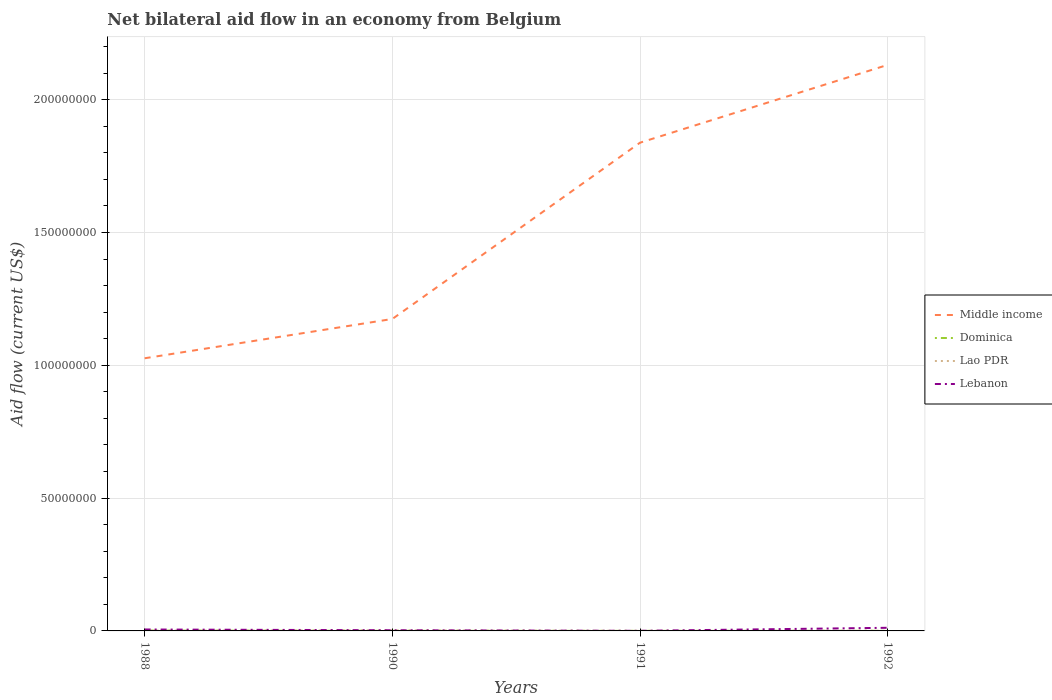How many different coloured lines are there?
Your answer should be very brief. 4. Across all years, what is the maximum net bilateral aid flow in Dominica?
Offer a terse response. 2.00e+04. In which year was the net bilateral aid flow in Lebanon maximum?
Give a very brief answer. 1991. What is the difference between the highest and the second highest net bilateral aid flow in Lao PDR?
Provide a short and direct response. 2.10e+05. What is the difference between the highest and the lowest net bilateral aid flow in Lebanon?
Provide a short and direct response. 2. How many lines are there?
Provide a succinct answer. 4. How many legend labels are there?
Your answer should be compact. 4. How are the legend labels stacked?
Provide a succinct answer. Vertical. What is the title of the graph?
Your response must be concise. Net bilateral aid flow in an economy from Belgium. What is the label or title of the Y-axis?
Ensure brevity in your answer.  Aid flow (current US$). What is the Aid flow (current US$) in Middle income in 1988?
Give a very brief answer. 1.03e+08. What is the Aid flow (current US$) of Dominica in 1988?
Your response must be concise. 1.20e+05. What is the Aid flow (current US$) of Lebanon in 1988?
Provide a succinct answer. 5.40e+05. What is the Aid flow (current US$) of Middle income in 1990?
Provide a short and direct response. 1.17e+08. What is the Aid flow (current US$) in Dominica in 1990?
Offer a very short reply. 4.00e+04. What is the Aid flow (current US$) of Lao PDR in 1990?
Your answer should be compact. 2.30e+05. What is the Aid flow (current US$) of Middle income in 1991?
Your answer should be very brief. 1.84e+08. What is the Aid flow (current US$) in Dominica in 1991?
Your answer should be very brief. 2.00e+04. What is the Aid flow (current US$) of Middle income in 1992?
Provide a short and direct response. 2.13e+08. What is the Aid flow (current US$) in Lebanon in 1992?
Your response must be concise. 1.18e+06. Across all years, what is the maximum Aid flow (current US$) in Middle income?
Your answer should be very brief. 2.13e+08. Across all years, what is the maximum Aid flow (current US$) in Dominica?
Offer a terse response. 1.20e+05. Across all years, what is the maximum Aid flow (current US$) in Lao PDR?
Provide a short and direct response. 2.30e+05. Across all years, what is the maximum Aid flow (current US$) in Lebanon?
Make the answer very short. 1.18e+06. Across all years, what is the minimum Aid flow (current US$) of Middle income?
Provide a succinct answer. 1.03e+08. Across all years, what is the minimum Aid flow (current US$) of Dominica?
Offer a terse response. 2.00e+04. Across all years, what is the minimum Aid flow (current US$) of Lao PDR?
Offer a very short reply. 2.00e+04. Across all years, what is the minimum Aid flow (current US$) of Lebanon?
Ensure brevity in your answer.  4.00e+04. What is the total Aid flow (current US$) in Middle income in the graph?
Provide a succinct answer. 6.17e+08. What is the total Aid flow (current US$) in Lao PDR in the graph?
Make the answer very short. 4.30e+05. What is the total Aid flow (current US$) in Lebanon in the graph?
Provide a short and direct response. 2.01e+06. What is the difference between the Aid flow (current US$) of Middle income in 1988 and that in 1990?
Provide a succinct answer. -1.48e+07. What is the difference between the Aid flow (current US$) of Dominica in 1988 and that in 1990?
Your answer should be very brief. 8.00e+04. What is the difference between the Aid flow (current US$) in Lebanon in 1988 and that in 1990?
Offer a very short reply. 2.90e+05. What is the difference between the Aid flow (current US$) in Middle income in 1988 and that in 1991?
Ensure brevity in your answer.  -8.12e+07. What is the difference between the Aid flow (current US$) in Dominica in 1988 and that in 1991?
Your answer should be compact. 1.00e+05. What is the difference between the Aid flow (current US$) in Lao PDR in 1988 and that in 1991?
Offer a very short reply. 9.00e+04. What is the difference between the Aid flow (current US$) in Lebanon in 1988 and that in 1991?
Keep it short and to the point. 5.00e+05. What is the difference between the Aid flow (current US$) of Middle income in 1988 and that in 1992?
Ensure brevity in your answer.  -1.10e+08. What is the difference between the Aid flow (current US$) in Lao PDR in 1988 and that in 1992?
Your response must be concise. 4.00e+04. What is the difference between the Aid flow (current US$) of Lebanon in 1988 and that in 1992?
Offer a terse response. -6.40e+05. What is the difference between the Aid flow (current US$) of Middle income in 1990 and that in 1991?
Your response must be concise. -6.64e+07. What is the difference between the Aid flow (current US$) of Lao PDR in 1990 and that in 1991?
Keep it short and to the point. 2.10e+05. What is the difference between the Aid flow (current US$) of Middle income in 1990 and that in 1992?
Offer a terse response. -9.57e+07. What is the difference between the Aid flow (current US$) in Dominica in 1990 and that in 1992?
Your response must be concise. 0. What is the difference between the Aid flow (current US$) of Lebanon in 1990 and that in 1992?
Your response must be concise. -9.30e+05. What is the difference between the Aid flow (current US$) in Middle income in 1991 and that in 1992?
Your answer should be compact. -2.93e+07. What is the difference between the Aid flow (current US$) in Dominica in 1991 and that in 1992?
Offer a very short reply. -2.00e+04. What is the difference between the Aid flow (current US$) in Lebanon in 1991 and that in 1992?
Your answer should be very brief. -1.14e+06. What is the difference between the Aid flow (current US$) of Middle income in 1988 and the Aid flow (current US$) of Dominica in 1990?
Provide a succinct answer. 1.03e+08. What is the difference between the Aid flow (current US$) in Middle income in 1988 and the Aid flow (current US$) in Lao PDR in 1990?
Provide a short and direct response. 1.02e+08. What is the difference between the Aid flow (current US$) of Middle income in 1988 and the Aid flow (current US$) of Lebanon in 1990?
Keep it short and to the point. 1.02e+08. What is the difference between the Aid flow (current US$) in Dominica in 1988 and the Aid flow (current US$) in Lebanon in 1990?
Your response must be concise. -1.30e+05. What is the difference between the Aid flow (current US$) of Lao PDR in 1988 and the Aid flow (current US$) of Lebanon in 1990?
Make the answer very short. -1.40e+05. What is the difference between the Aid flow (current US$) in Middle income in 1988 and the Aid flow (current US$) in Dominica in 1991?
Make the answer very short. 1.03e+08. What is the difference between the Aid flow (current US$) in Middle income in 1988 and the Aid flow (current US$) in Lao PDR in 1991?
Keep it short and to the point. 1.03e+08. What is the difference between the Aid flow (current US$) of Middle income in 1988 and the Aid flow (current US$) of Lebanon in 1991?
Your answer should be compact. 1.03e+08. What is the difference between the Aid flow (current US$) of Dominica in 1988 and the Aid flow (current US$) of Lao PDR in 1991?
Make the answer very short. 1.00e+05. What is the difference between the Aid flow (current US$) of Lao PDR in 1988 and the Aid flow (current US$) of Lebanon in 1991?
Offer a very short reply. 7.00e+04. What is the difference between the Aid flow (current US$) of Middle income in 1988 and the Aid flow (current US$) of Dominica in 1992?
Offer a very short reply. 1.03e+08. What is the difference between the Aid flow (current US$) of Middle income in 1988 and the Aid flow (current US$) of Lao PDR in 1992?
Offer a very short reply. 1.03e+08. What is the difference between the Aid flow (current US$) of Middle income in 1988 and the Aid flow (current US$) of Lebanon in 1992?
Your answer should be very brief. 1.01e+08. What is the difference between the Aid flow (current US$) of Dominica in 1988 and the Aid flow (current US$) of Lebanon in 1992?
Your answer should be very brief. -1.06e+06. What is the difference between the Aid flow (current US$) in Lao PDR in 1988 and the Aid flow (current US$) in Lebanon in 1992?
Make the answer very short. -1.07e+06. What is the difference between the Aid flow (current US$) of Middle income in 1990 and the Aid flow (current US$) of Dominica in 1991?
Offer a terse response. 1.17e+08. What is the difference between the Aid flow (current US$) of Middle income in 1990 and the Aid flow (current US$) of Lao PDR in 1991?
Keep it short and to the point. 1.17e+08. What is the difference between the Aid flow (current US$) in Middle income in 1990 and the Aid flow (current US$) in Lebanon in 1991?
Your answer should be very brief. 1.17e+08. What is the difference between the Aid flow (current US$) of Dominica in 1990 and the Aid flow (current US$) of Lao PDR in 1991?
Offer a terse response. 2.00e+04. What is the difference between the Aid flow (current US$) in Dominica in 1990 and the Aid flow (current US$) in Lebanon in 1991?
Make the answer very short. 0. What is the difference between the Aid flow (current US$) in Lao PDR in 1990 and the Aid flow (current US$) in Lebanon in 1991?
Your response must be concise. 1.90e+05. What is the difference between the Aid flow (current US$) in Middle income in 1990 and the Aid flow (current US$) in Dominica in 1992?
Your response must be concise. 1.17e+08. What is the difference between the Aid flow (current US$) in Middle income in 1990 and the Aid flow (current US$) in Lao PDR in 1992?
Give a very brief answer. 1.17e+08. What is the difference between the Aid flow (current US$) of Middle income in 1990 and the Aid flow (current US$) of Lebanon in 1992?
Your answer should be compact. 1.16e+08. What is the difference between the Aid flow (current US$) in Dominica in 1990 and the Aid flow (current US$) in Lebanon in 1992?
Provide a succinct answer. -1.14e+06. What is the difference between the Aid flow (current US$) in Lao PDR in 1990 and the Aid flow (current US$) in Lebanon in 1992?
Offer a very short reply. -9.50e+05. What is the difference between the Aid flow (current US$) of Middle income in 1991 and the Aid flow (current US$) of Dominica in 1992?
Offer a terse response. 1.84e+08. What is the difference between the Aid flow (current US$) of Middle income in 1991 and the Aid flow (current US$) of Lao PDR in 1992?
Provide a succinct answer. 1.84e+08. What is the difference between the Aid flow (current US$) in Middle income in 1991 and the Aid flow (current US$) in Lebanon in 1992?
Make the answer very short. 1.83e+08. What is the difference between the Aid flow (current US$) of Dominica in 1991 and the Aid flow (current US$) of Lebanon in 1992?
Provide a succinct answer. -1.16e+06. What is the difference between the Aid flow (current US$) in Lao PDR in 1991 and the Aid flow (current US$) in Lebanon in 1992?
Provide a short and direct response. -1.16e+06. What is the average Aid flow (current US$) in Middle income per year?
Provide a succinct answer. 1.54e+08. What is the average Aid flow (current US$) of Dominica per year?
Provide a succinct answer. 5.50e+04. What is the average Aid flow (current US$) in Lao PDR per year?
Offer a terse response. 1.08e+05. What is the average Aid flow (current US$) in Lebanon per year?
Your answer should be very brief. 5.02e+05. In the year 1988, what is the difference between the Aid flow (current US$) of Middle income and Aid flow (current US$) of Dominica?
Your response must be concise. 1.03e+08. In the year 1988, what is the difference between the Aid flow (current US$) of Middle income and Aid flow (current US$) of Lao PDR?
Make the answer very short. 1.03e+08. In the year 1988, what is the difference between the Aid flow (current US$) in Middle income and Aid flow (current US$) in Lebanon?
Offer a very short reply. 1.02e+08. In the year 1988, what is the difference between the Aid flow (current US$) in Dominica and Aid flow (current US$) in Lao PDR?
Your answer should be very brief. 10000. In the year 1988, what is the difference between the Aid flow (current US$) in Dominica and Aid flow (current US$) in Lebanon?
Offer a terse response. -4.20e+05. In the year 1988, what is the difference between the Aid flow (current US$) in Lao PDR and Aid flow (current US$) in Lebanon?
Ensure brevity in your answer.  -4.30e+05. In the year 1990, what is the difference between the Aid flow (current US$) of Middle income and Aid flow (current US$) of Dominica?
Keep it short and to the point. 1.17e+08. In the year 1990, what is the difference between the Aid flow (current US$) in Middle income and Aid flow (current US$) in Lao PDR?
Offer a terse response. 1.17e+08. In the year 1990, what is the difference between the Aid flow (current US$) in Middle income and Aid flow (current US$) in Lebanon?
Your response must be concise. 1.17e+08. In the year 1990, what is the difference between the Aid flow (current US$) in Lao PDR and Aid flow (current US$) in Lebanon?
Keep it short and to the point. -2.00e+04. In the year 1991, what is the difference between the Aid flow (current US$) of Middle income and Aid flow (current US$) of Dominica?
Offer a very short reply. 1.84e+08. In the year 1991, what is the difference between the Aid flow (current US$) in Middle income and Aid flow (current US$) in Lao PDR?
Provide a short and direct response. 1.84e+08. In the year 1991, what is the difference between the Aid flow (current US$) in Middle income and Aid flow (current US$) in Lebanon?
Make the answer very short. 1.84e+08. In the year 1991, what is the difference between the Aid flow (current US$) of Dominica and Aid flow (current US$) of Lao PDR?
Ensure brevity in your answer.  0. In the year 1991, what is the difference between the Aid flow (current US$) in Dominica and Aid flow (current US$) in Lebanon?
Your response must be concise. -2.00e+04. In the year 1992, what is the difference between the Aid flow (current US$) in Middle income and Aid flow (current US$) in Dominica?
Make the answer very short. 2.13e+08. In the year 1992, what is the difference between the Aid flow (current US$) in Middle income and Aid flow (current US$) in Lao PDR?
Your answer should be very brief. 2.13e+08. In the year 1992, what is the difference between the Aid flow (current US$) of Middle income and Aid flow (current US$) of Lebanon?
Provide a short and direct response. 2.12e+08. In the year 1992, what is the difference between the Aid flow (current US$) in Dominica and Aid flow (current US$) in Lao PDR?
Give a very brief answer. -3.00e+04. In the year 1992, what is the difference between the Aid flow (current US$) in Dominica and Aid flow (current US$) in Lebanon?
Your answer should be very brief. -1.14e+06. In the year 1992, what is the difference between the Aid flow (current US$) of Lao PDR and Aid flow (current US$) of Lebanon?
Your answer should be very brief. -1.11e+06. What is the ratio of the Aid flow (current US$) in Middle income in 1988 to that in 1990?
Your response must be concise. 0.87. What is the ratio of the Aid flow (current US$) in Lao PDR in 1988 to that in 1990?
Ensure brevity in your answer.  0.48. What is the ratio of the Aid flow (current US$) of Lebanon in 1988 to that in 1990?
Give a very brief answer. 2.16. What is the ratio of the Aid flow (current US$) of Middle income in 1988 to that in 1991?
Your answer should be very brief. 0.56. What is the ratio of the Aid flow (current US$) in Dominica in 1988 to that in 1991?
Ensure brevity in your answer.  6. What is the ratio of the Aid flow (current US$) of Middle income in 1988 to that in 1992?
Your answer should be compact. 0.48. What is the ratio of the Aid flow (current US$) in Dominica in 1988 to that in 1992?
Give a very brief answer. 3. What is the ratio of the Aid flow (current US$) in Lao PDR in 1988 to that in 1992?
Make the answer very short. 1.57. What is the ratio of the Aid flow (current US$) of Lebanon in 1988 to that in 1992?
Offer a terse response. 0.46. What is the ratio of the Aid flow (current US$) of Middle income in 1990 to that in 1991?
Offer a terse response. 0.64. What is the ratio of the Aid flow (current US$) in Lebanon in 1990 to that in 1991?
Provide a short and direct response. 6.25. What is the ratio of the Aid flow (current US$) of Middle income in 1990 to that in 1992?
Offer a terse response. 0.55. What is the ratio of the Aid flow (current US$) of Lao PDR in 1990 to that in 1992?
Your response must be concise. 3.29. What is the ratio of the Aid flow (current US$) in Lebanon in 1990 to that in 1992?
Your answer should be very brief. 0.21. What is the ratio of the Aid flow (current US$) in Middle income in 1991 to that in 1992?
Your answer should be compact. 0.86. What is the ratio of the Aid flow (current US$) in Lao PDR in 1991 to that in 1992?
Provide a short and direct response. 0.29. What is the ratio of the Aid flow (current US$) in Lebanon in 1991 to that in 1992?
Make the answer very short. 0.03. What is the difference between the highest and the second highest Aid flow (current US$) in Middle income?
Provide a succinct answer. 2.93e+07. What is the difference between the highest and the second highest Aid flow (current US$) of Lebanon?
Your answer should be very brief. 6.40e+05. What is the difference between the highest and the lowest Aid flow (current US$) in Middle income?
Ensure brevity in your answer.  1.10e+08. What is the difference between the highest and the lowest Aid flow (current US$) in Lebanon?
Make the answer very short. 1.14e+06. 